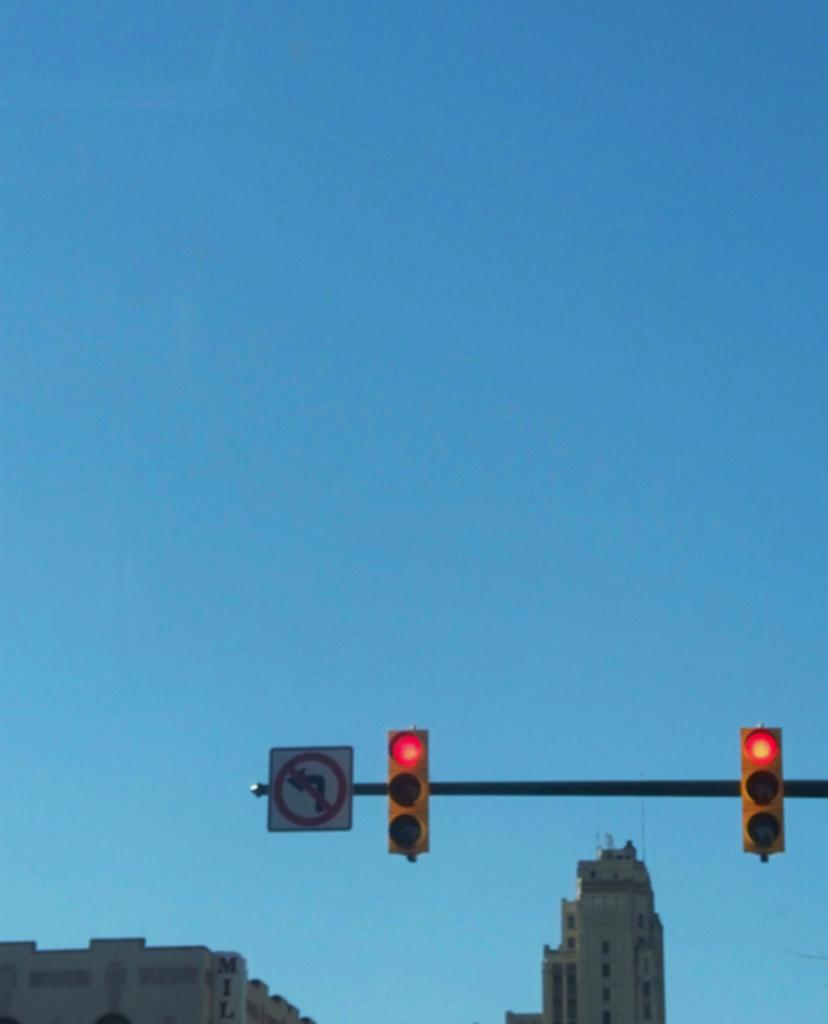What type of infrastructure is present in the image? There are traffic lights and buildings in the image. Can you describe the traffic lights in the image? The traffic lights are present to regulate the flow of traffic. What type of structures can be seen in the image? There are buildings in the image. What discovery was made in the building in the image? There is no information about any discovery in the image; it only shows traffic lights and buildings. Who is cooking in the building in the image? There is no indication of anyone cooking in the image; it only shows traffic lights and buildings. 